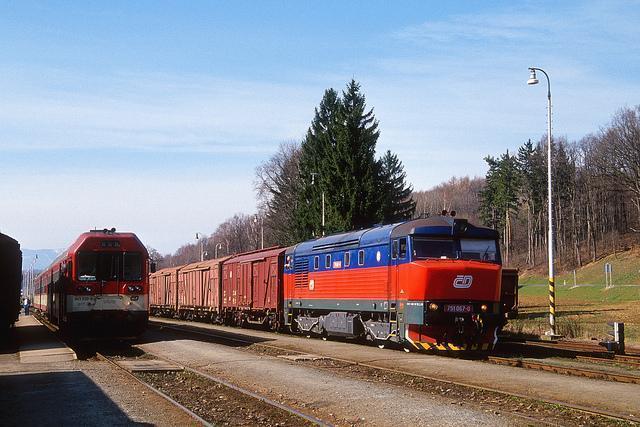How many trains are there?
Give a very brief answer. 2. 